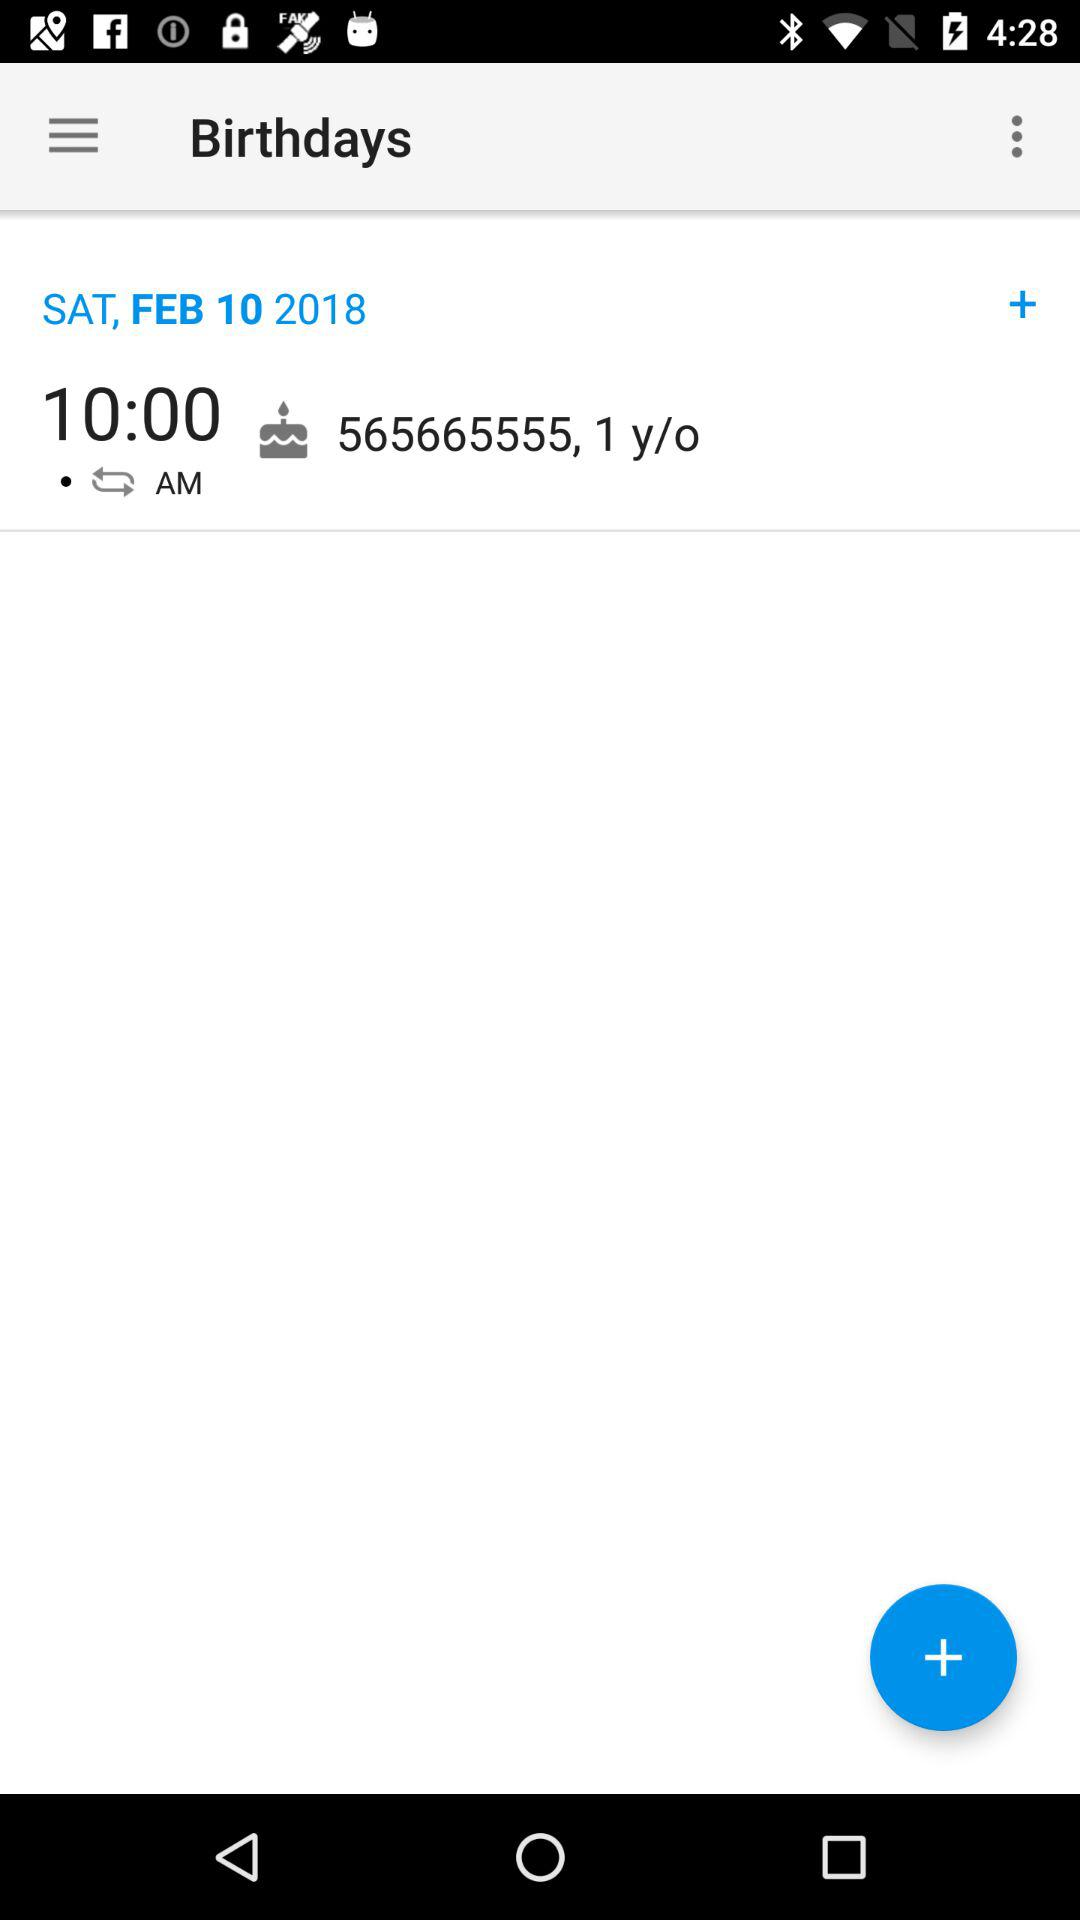What time is the birthday reminder set for? The birthday reminder is set for 10:00 a.m. 